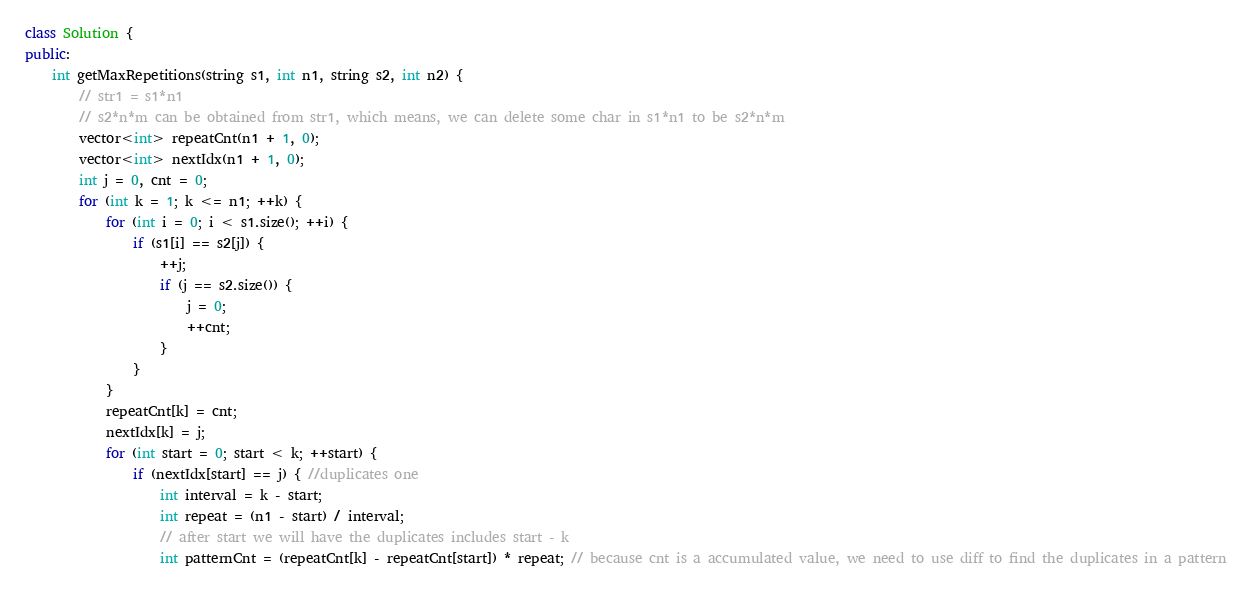Convert code to text. <code><loc_0><loc_0><loc_500><loc_500><_C++_>class Solution {
public:
    int getMaxRepetitions(string s1, int n1, string s2, int n2) {
        // str1 = s1*n1
        // s2*n*m can be obtained from str1, which means, we can delete some char in s1*n1 to be s2*n*m
        vector<int> repeatCnt(n1 + 1, 0);
        vector<int> nextIdx(n1 + 1, 0);
        int j = 0, cnt = 0;
        for (int k = 1; k <= n1; ++k) {
            for (int i = 0; i < s1.size(); ++i) {
                if (s1[i] == s2[j]) {
                    ++j;
                    if (j == s2.size()) {  
                        j = 0;
                        ++cnt;
                    }
                }
            }
            repeatCnt[k] = cnt;
            nextIdx[k] = j;
            for (int start = 0; start < k; ++start) {
                if (nextIdx[start] == j) { //duplicates one
                    int interval = k - start;
                    int repeat = (n1 - start) / interval;
                    // after start we will have the duplicates includes start - k
                    int patternCnt = (repeatCnt[k] - repeatCnt[start]) * repeat; // because cnt is a accumulated value, we need to use diff to find the duplicates in a pattern
</code> 